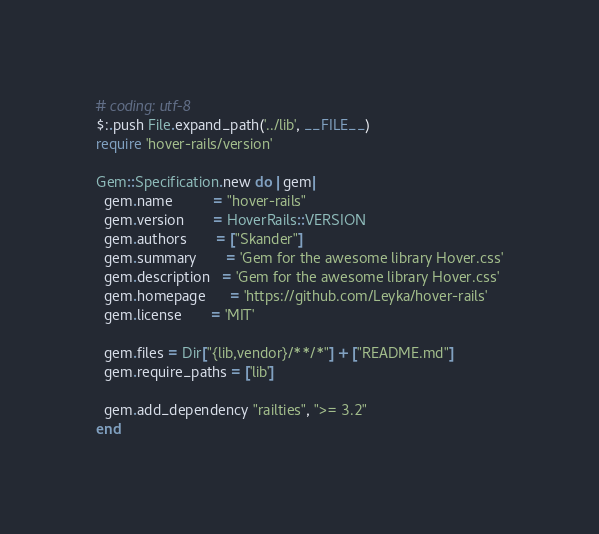<code> <loc_0><loc_0><loc_500><loc_500><_Ruby_># coding: utf-8
$:.push File.expand_path('../lib', __FILE__)
require 'hover-rails/version'

Gem::Specification.new do |gem|
  gem.name          = "hover-rails"
  gem.version       = HoverRails::VERSION
  gem.authors       = ["Skander"]
  gem.summary       = 'Gem for the awesome library Hover.css'
  gem.description   = 'Gem for the awesome library Hover.css'
  gem.homepage      = 'https://github.com/Leyka/hover-rails'
  gem.license       = 'MIT'

  gem.files = Dir["{lib,vendor}/**/*"] + ["README.md"]
  gem.require_paths = ['lib']

  gem.add_dependency "railties", ">= 3.2"
end
</code> 